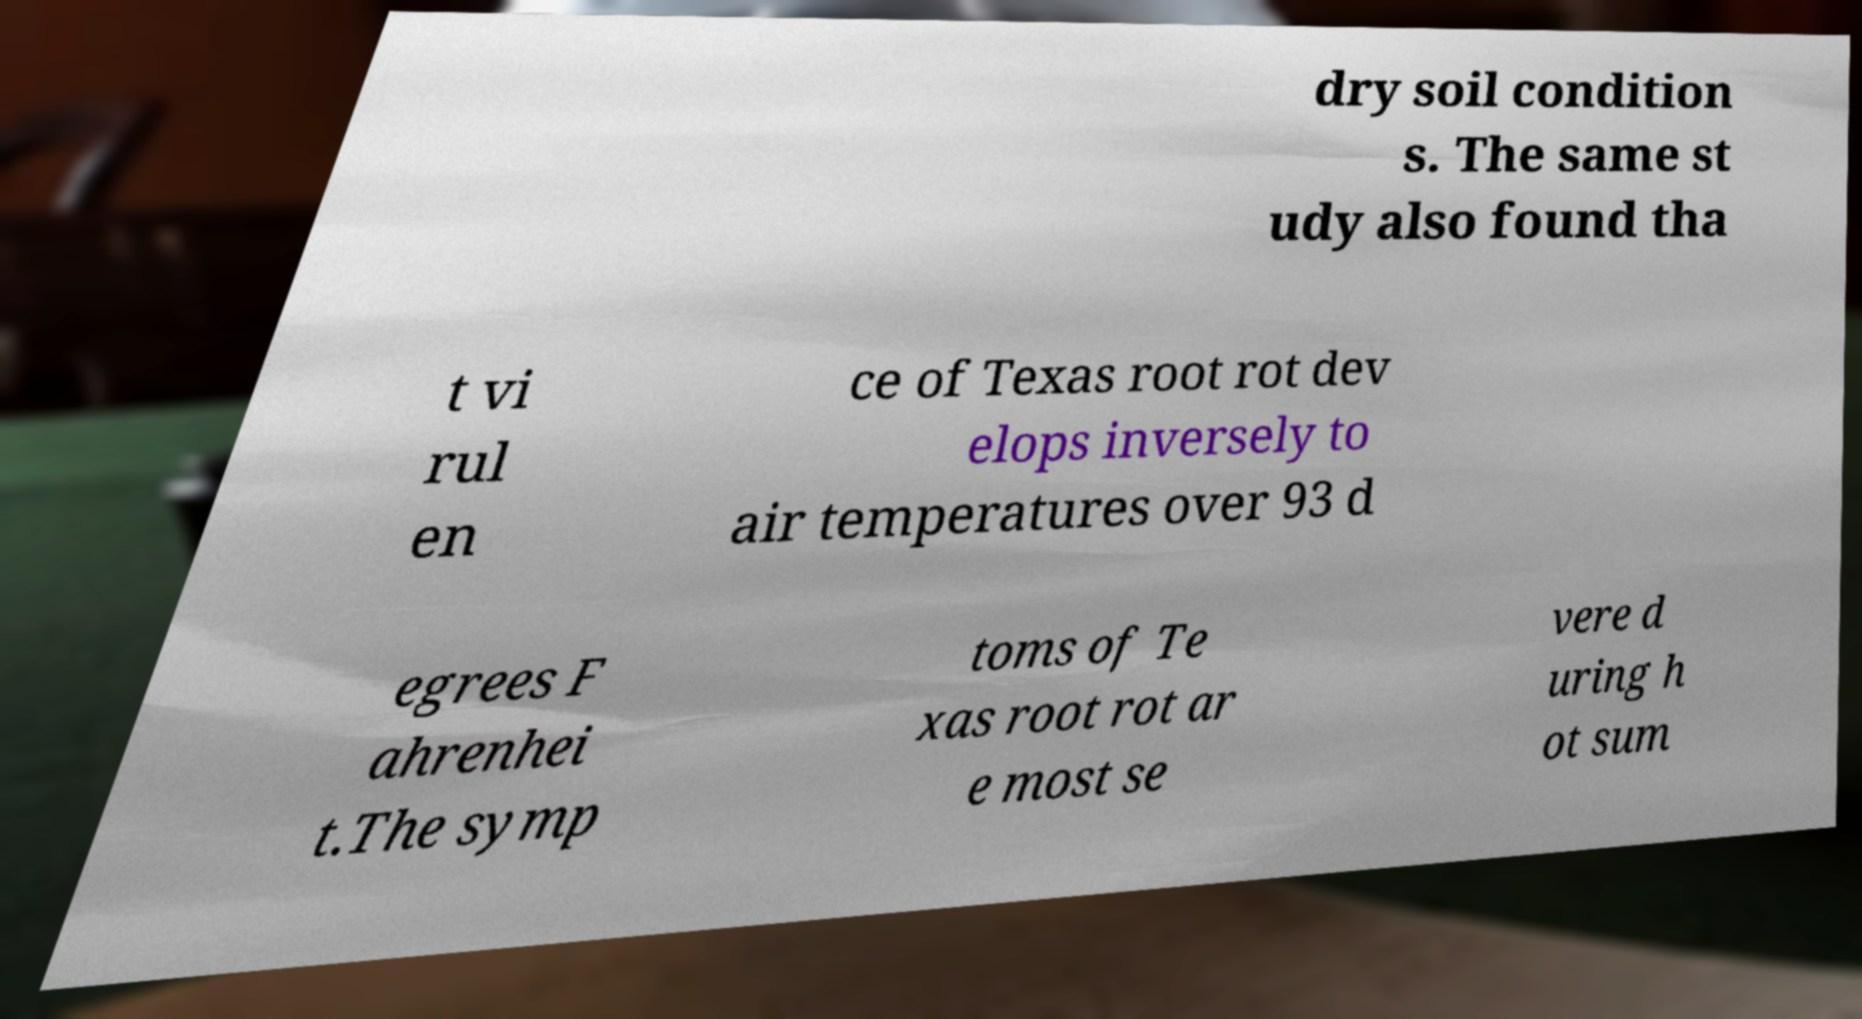What messages or text are displayed in this image? I need them in a readable, typed format. dry soil condition s. The same st udy also found tha t vi rul en ce of Texas root rot dev elops inversely to air temperatures over 93 d egrees F ahrenhei t.The symp toms of Te xas root rot ar e most se vere d uring h ot sum 